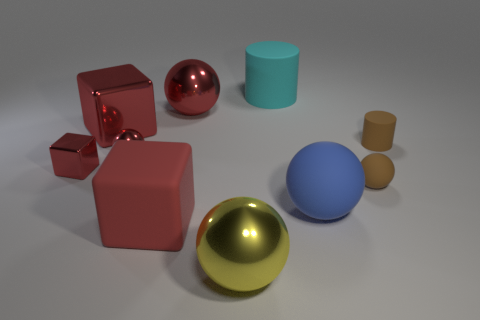There is a tiny cube that is the same color as the tiny metallic sphere; what is its material?
Keep it short and to the point. Metal. How many other rubber cubes have the same color as the small block?
Make the answer very short. 1. The brown sphere is what size?
Make the answer very short. Small. Does the large yellow metal object have the same shape as the big rubber thing on the left side of the big cyan rubber thing?
Give a very brief answer. No. There is a big block that is the same material as the yellow object; what color is it?
Ensure brevity in your answer.  Red. There is a cylinder that is to the right of the big rubber cylinder; what size is it?
Offer a very short reply. Small. Are there fewer large cyan objects that are in front of the rubber block than brown metal blocks?
Make the answer very short. No. Does the small metallic block have the same color as the large cylinder?
Ensure brevity in your answer.  No. Are there fewer big matte things than large brown rubber cylinders?
Keep it short and to the point. No. The rubber cylinder that is in front of the large metal sphere behind the yellow sphere is what color?
Make the answer very short. Brown. 